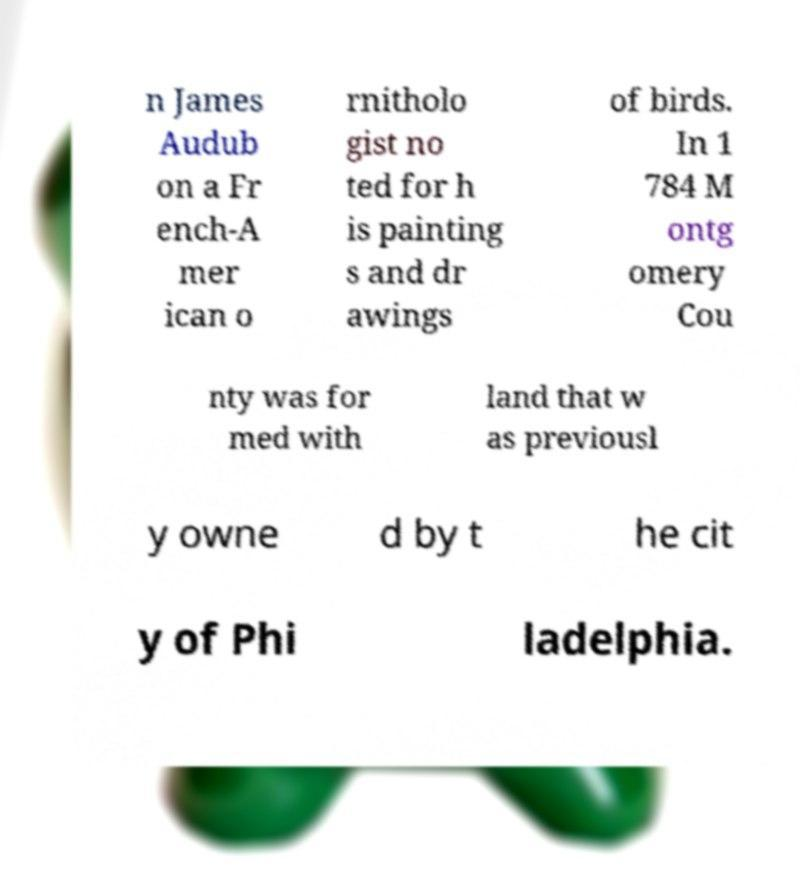Could you extract and type out the text from this image? n James Audub on a Fr ench-A mer ican o rnitholo gist no ted for h is painting s and dr awings of birds. In 1 784 M ontg omery Cou nty was for med with land that w as previousl y owne d by t he cit y of Phi ladelphia. 